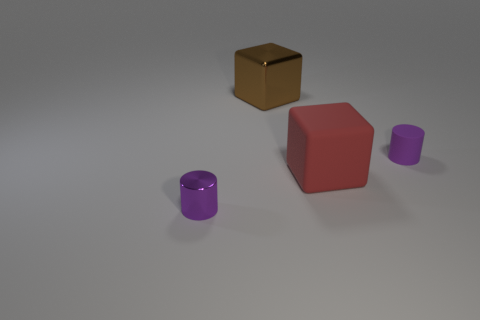What kind of material do the objects seem to be made of based on their appearance? Based on their appearance, the purple cylinder and the red cube seem to have a matte, rubber-like texture. In contrast, the golden box appears to be metallic with a smooth, reflective surface, possibly indicative of a polished metal. 